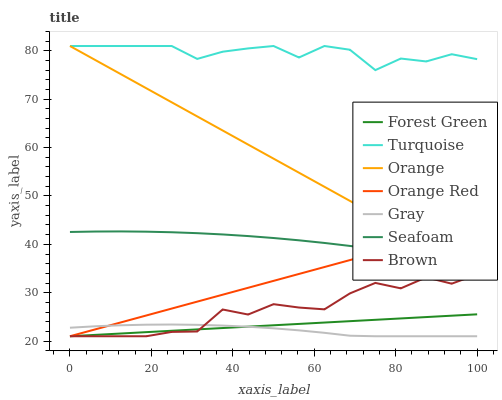Does Gray have the minimum area under the curve?
Answer yes or no. Yes. Does Turquoise have the maximum area under the curve?
Answer yes or no. Yes. Does Brown have the minimum area under the curve?
Answer yes or no. No. Does Brown have the maximum area under the curve?
Answer yes or no. No. Is Forest Green the smoothest?
Answer yes or no. Yes. Is Brown the roughest?
Answer yes or no. Yes. Is Turquoise the smoothest?
Answer yes or no. No. Is Turquoise the roughest?
Answer yes or no. No. Does Gray have the lowest value?
Answer yes or no. Yes. Does Turquoise have the lowest value?
Answer yes or no. No. Does Orange have the highest value?
Answer yes or no. Yes. Does Brown have the highest value?
Answer yes or no. No. Is Forest Green less than Seafoam?
Answer yes or no. Yes. Is Turquoise greater than Seafoam?
Answer yes or no. Yes. Does Brown intersect Orange Red?
Answer yes or no. Yes. Is Brown less than Orange Red?
Answer yes or no. No. Is Brown greater than Orange Red?
Answer yes or no. No. Does Forest Green intersect Seafoam?
Answer yes or no. No. 